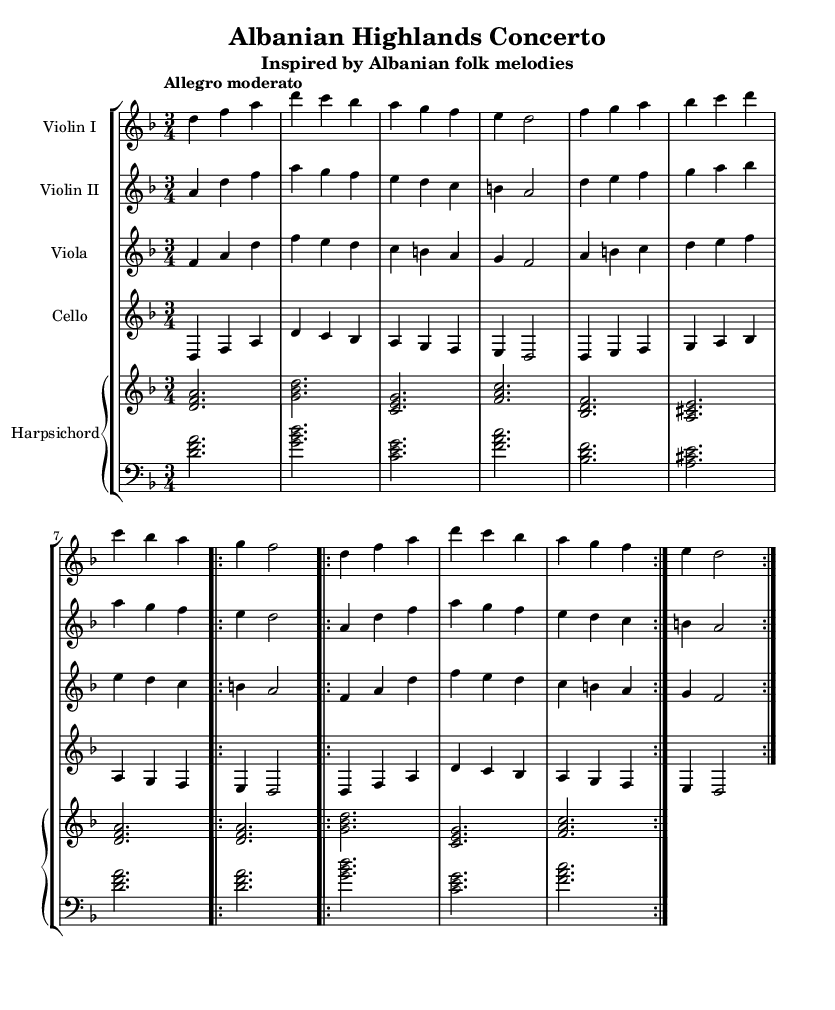What is the key signature of this music? The key signature in the piece is D minor, which indicates one flat (B flat). This is determined by examining the notation at the beginning of the music, where the key signature is placed.
Answer: D minor What is the time signature of this music? The time signature is 3/4, indicating that there are three beats in each measure, and the quarter note gets one beat. This can be found in the measures at the beginning of the score where the time signature is indicated.
Answer: 3/4 What is the tempo marking of this piece? The tempo marking is "Allegro moderato," which indicates a moderately fast tempo. This is indicated at the start of the piece in the tempo text above the staff.
Answer: Allegro moderato How many measures are in the repeated section for violin I? The repeated section for violin I consists of 8 measures, as the repeat is indicated after the first 4 measures are played twice, making a total of 8 measures.
Answer: 8 measures Which instruments are included in this chamber music piece? The instruments included are two violins, a viola, a cello, and a harpsichord. This can be discerned by checking the staff labels throughout the score which identify each instrument.
Answer: Violin I, Violin II, Viola, Cello, Harpsichord What type of music structure is predominantly used in this piece? The predominant music structure used in this piece is a theme with variations, as it features repeating sections with slight variations in instrumentation and melody. This can be understood by observing the repeat indications and the variations in the parts.
Answer: Theme with variations 